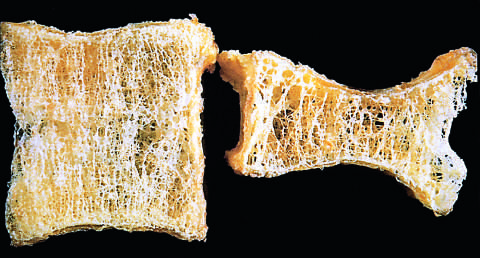what is shortened by compression fractures?
Answer the question using a single word or phrase. The osteoporotic vertebral body 